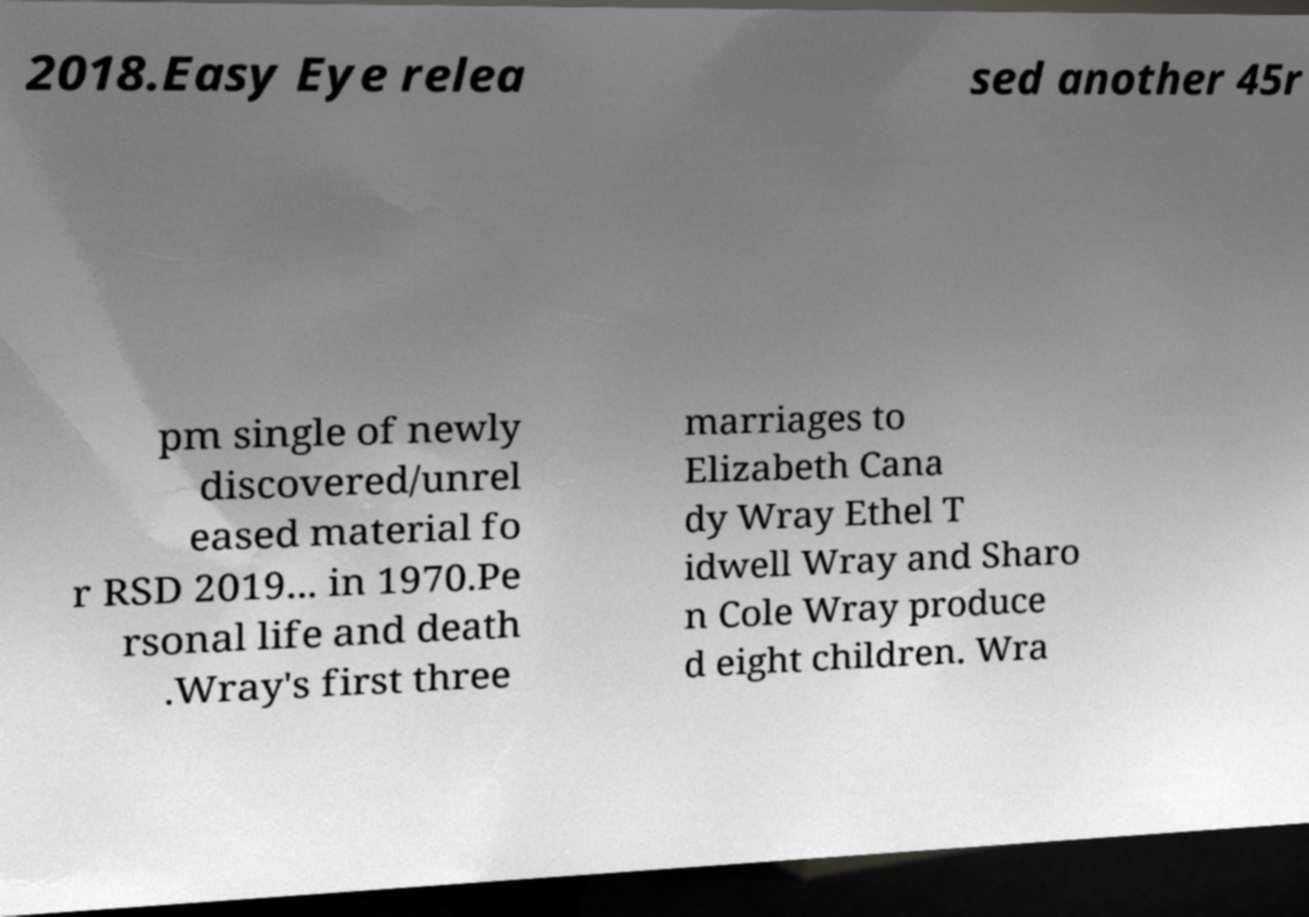I need the written content from this picture converted into text. Can you do that? 2018.Easy Eye relea sed another 45r pm single of newly discovered/unrel eased material fo r RSD 2019... in 1970.Pe rsonal life and death .Wray's first three marriages to Elizabeth Cana dy Wray Ethel T idwell Wray and Sharo n Cole Wray produce d eight children. Wra 